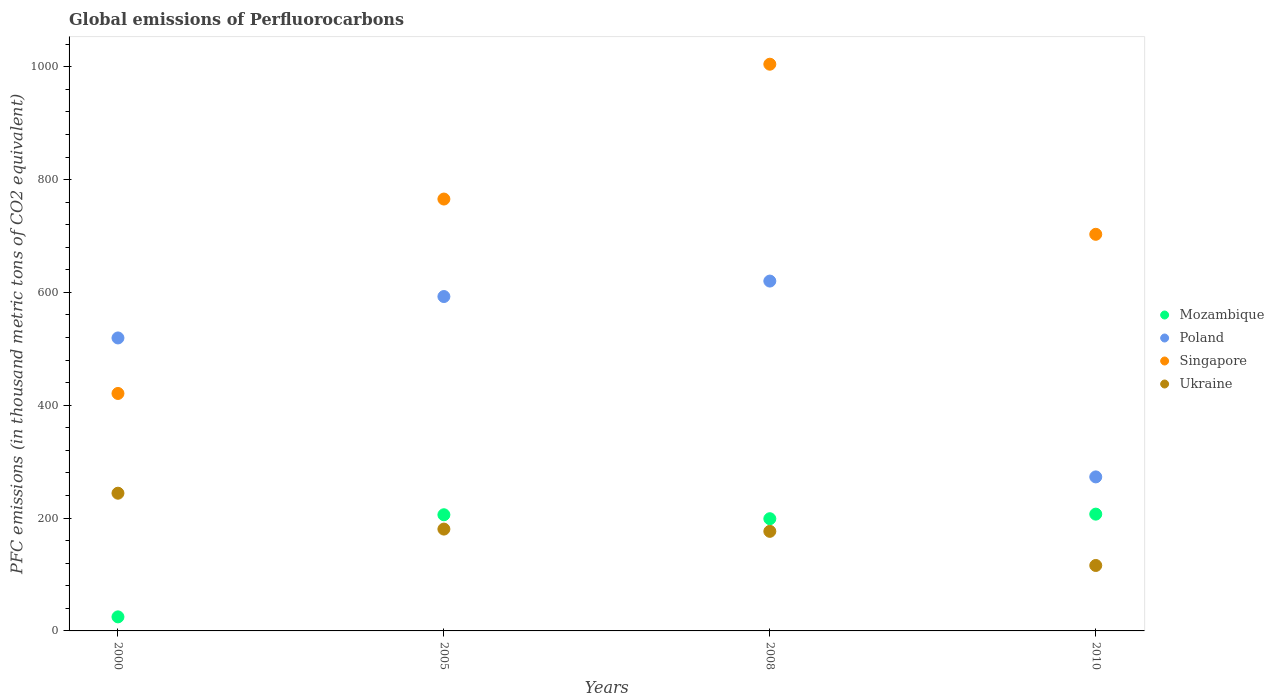What is the global emissions of Perfluorocarbons in Ukraine in 2005?
Provide a succinct answer. 180.5. Across all years, what is the maximum global emissions of Perfluorocarbons in Poland?
Offer a terse response. 620.1. Across all years, what is the minimum global emissions of Perfluorocarbons in Ukraine?
Your answer should be very brief. 116. In which year was the global emissions of Perfluorocarbons in Poland maximum?
Make the answer very short. 2008. In which year was the global emissions of Perfluorocarbons in Mozambique minimum?
Your answer should be very brief. 2000. What is the total global emissions of Perfluorocarbons in Singapore in the graph?
Offer a terse response. 2893.9. What is the difference between the global emissions of Perfluorocarbons in Singapore in 2000 and that in 2005?
Your answer should be very brief. -344.6. What is the difference between the global emissions of Perfluorocarbons in Poland in 2000 and the global emissions of Perfluorocarbons in Mozambique in 2010?
Offer a terse response. 312.3. What is the average global emissions of Perfluorocarbons in Mozambique per year?
Make the answer very short. 159.18. In the year 2010, what is the difference between the global emissions of Perfluorocarbons in Mozambique and global emissions of Perfluorocarbons in Ukraine?
Your answer should be compact. 91. What is the ratio of the global emissions of Perfluorocarbons in Mozambique in 2005 to that in 2008?
Provide a succinct answer. 1.04. What is the difference between the highest and the second highest global emissions of Perfluorocarbons in Singapore?
Make the answer very short. 239. What is the difference between the highest and the lowest global emissions of Perfluorocarbons in Mozambique?
Your answer should be compact. 182.1. In how many years, is the global emissions of Perfluorocarbons in Ukraine greater than the average global emissions of Perfluorocarbons in Ukraine taken over all years?
Your answer should be compact. 2. Is the sum of the global emissions of Perfluorocarbons in Mozambique in 2000 and 2005 greater than the maximum global emissions of Perfluorocarbons in Poland across all years?
Your response must be concise. No. Is the global emissions of Perfluorocarbons in Poland strictly greater than the global emissions of Perfluorocarbons in Ukraine over the years?
Keep it short and to the point. Yes. Is the global emissions of Perfluorocarbons in Mozambique strictly less than the global emissions of Perfluorocarbons in Singapore over the years?
Make the answer very short. Yes. How many dotlines are there?
Offer a very short reply. 4. How many years are there in the graph?
Provide a succinct answer. 4. Are the values on the major ticks of Y-axis written in scientific E-notation?
Your answer should be very brief. No. How are the legend labels stacked?
Your answer should be very brief. Vertical. What is the title of the graph?
Provide a short and direct response. Global emissions of Perfluorocarbons. What is the label or title of the X-axis?
Make the answer very short. Years. What is the label or title of the Y-axis?
Keep it short and to the point. PFC emissions (in thousand metric tons of CO2 equivalent). What is the PFC emissions (in thousand metric tons of CO2 equivalent) in Mozambique in 2000?
Give a very brief answer. 24.9. What is the PFC emissions (in thousand metric tons of CO2 equivalent) of Poland in 2000?
Your answer should be very brief. 519.3. What is the PFC emissions (in thousand metric tons of CO2 equivalent) of Singapore in 2000?
Make the answer very short. 420.9. What is the PFC emissions (in thousand metric tons of CO2 equivalent) of Ukraine in 2000?
Offer a very short reply. 244.1. What is the PFC emissions (in thousand metric tons of CO2 equivalent) of Mozambique in 2005?
Your response must be concise. 205.9. What is the PFC emissions (in thousand metric tons of CO2 equivalent) of Poland in 2005?
Provide a short and direct response. 592.7. What is the PFC emissions (in thousand metric tons of CO2 equivalent) in Singapore in 2005?
Keep it short and to the point. 765.5. What is the PFC emissions (in thousand metric tons of CO2 equivalent) of Ukraine in 2005?
Your response must be concise. 180.5. What is the PFC emissions (in thousand metric tons of CO2 equivalent) in Mozambique in 2008?
Your answer should be very brief. 198.9. What is the PFC emissions (in thousand metric tons of CO2 equivalent) in Poland in 2008?
Give a very brief answer. 620.1. What is the PFC emissions (in thousand metric tons of CO2 equivalent) in Singapore in 2008?
Keep it short and to the point. 1004.5. What is the PFC emissions (in thousand metric tons of CO2 equivalent) in Ukraine in 2008?
Ensure brevity in your answer.  176.5. What is the PFC emissions (in thousand metric tons of CO2 equivalent) in Mozambique in 2010?
Your answer should be very brief. 207. What is the PFC emissions (in thousand metric tons of CO2 equivalent) in Poland in 2010?
Your answer should be compact. 273. What is the PFC emissions (in thousand metric tons of CO2 equivalent) in Singapore in 2010?
Your response must be concise. 703. What is the PFC emissions (in thousand metric tons of CO2 equivalent) of Ukraine in 2010?
Your answer should be compact. 116. Across all years, what is the maximum PFC emissions (in thousand metric tons of CO2 equivalent) in Mozambique?
Your answer should be compact. 207. Across all years, what is the maximum PFC emissions (in thousand metric tons of CO2 equivalent) in Poland?
Provide a short and direct response. 620.1. Across all years, what is the maximum PFC emissions (in thousand metric tons of CO2 equivalent) of Singapore?
Keep it short and to the point. 1004.5. Across all years, what is the maximum PFC emissions (in thousand metric tons of CO2 equivalent) of Ukraine?
Provide a succinct answer. 244.1. Across all years, what is the minimum PFC emissions (in thousand metric tons of CO2 equivalent) in Mozambique?
Give a very brief answer. 24.9. Across all years, what is the minimum PFC emissions (in thousand metric tons of CO2 equivalent) in Poland?
Offer a terse response. 273. Across all years, what is the minimum PFC emissions (in thousand metric tons of CO2 equivalent) in Singapore?
Your answer should be compact. 420.9. Across all years, what is the minimum PFC emissions (in thousand metric tons of CO2 equivalent) of Ukraine?
Ensure brevity in your answer.  116. What is the total PFC emissions (in thousand metric tons of CO2 equivalent) in Mozambique in the graph?
Provide a short and direct response. 636.7. What is the total PFC emissions (in thousand metric tons of CO2 equivalent) in Poland in the graph?
Offer a very short reply. 2005.1. What is the total PFC emissions (in thousand metric tons of CO2 equivalent) of Singapore in the graph?
Keep it short and to the point. 2893.9. What is the total PFC emissions (in thousand metric tons of CO2 equivalent) in Ukraine in the graph?
Give a very brief answer. 717.1. What is the difference between the PFC emissions (in thousand metric tons of CO2 equivalent) of Mozambique in 2000 and that in 2005?
Your response must be concise. -181. What is the difference between the PFC emissions (in thousand metric tons of CO2 equivalent) of Poland in 2000 and that in 2005?
Keep it short and to the point. -73.4. What is the difference between the PFC emissions (in thousand metric tons of CO2 equivalent) of Singapore in 2000 and that in 2005?
Keep it short and to the point. -344.6. What is the difference between the PFC emissions (in thousand metric tons of CO2 equivalent) of Ukraine in 2000 and that in 2005?
Your answer should be very brief. 63.6. What is the difference between the PFC emissions (in thousand metric tons of CO2 equivalent) in Mozambique in 2000 and that in 2008?
Ensure brevity in your answer.  -174. What is the difference between the PFC emissions (in thousand metric tons of CO2 equivalent) in Poland in 2000 and that in 2008?
Your answer should be compact. -100.8. What is the difference between the PFC emissions (in thousand metric tons of CO2 equivalent) of Singapore in 2000 and that in 2008?
Your answer should be compact. -583.6. What is the difference between the PFC emissions (in thousand metric tons of CO2 equivalent) in Ukraine in 2000 and that in 2008?
Your response must be concise. 67.6. What is the difference between the PFC emissions (in thousand metric tons of CO2 equivalent) of Mozambique in 2000 and that in 2010?
Your response must be concise. -182.1. What is the difference between the PFC emissions (in thousand metric tons of CO2 equivalent) in Poland in 2000 and that in 2010?
Make the answer very short. 246.3. What is the difference between the PFC emissions (in thousand metric tons of CO2 equivalent) of Singapore in 2000 and that in 2010?
Ensure brevity in your answer.  -282.1. What is the difference between the PFC emissions (in thousand metric tons of CO2 equivalent) of Ukraine in 2000 and that in 2010?
Keep it short and to the point. 128.1. What is the difference between the PFC emissions (in thousand metric tons of CO2 equivalent) of Mozambique in 2005 and that in 2008?
Keep it short and to the point. 7. What is the difference between the PFC emissions (in thousand metric tons of CO2 equivalent) in Poland in 2005 and that in 2008?
Make the answer very short. -27.4. What is the difference between the PFC emissions (in thousand metric tons of CO2 equivalent) in Singapore in 2005 and that in 2008?
Provide a succinct answer. -239. What is the difference between the PFC emissions (in thousand metric tons of CO2 equivalent) of Ukraine in 2005 and that in 2008?
Offer a very short reply. 4. What is the difference between the PFC emissions (in thousand metric tons of CO2 equivalent) of Poland in 2005 and that in 2010?
Your answer should be very brief. 319.7. What is the difference between the PFC emissions (in thousand metric tons of CO2 equivalent) of Singapore in 2005 and that in 2010?
Make the answer very short. 62.5. What is the difference between the PFC emissions (in thousand metric tons of CO2 equivalent) in Ukraine in 2005 and that in 2010?
Your answer should be very brief. 64.5. What is the difference between the PFC emissions (in thousand metric tons of CO2 equivalent) in Poland in 2008 and that in 2010?
Your answer should be very brief. 347.1. What is the difference between the PFC emissions (in thousand metric tons of CO2 equivalent) of Singapore in 2008 and that in 2010?
Provide a short and direct response. 301.5. What is the difference between the PFC emissions (in thousand metric tons of CO2 equivalent) of Ukraine in 2008 and that in 2010?
Ensure brevity in your answer.  60.5. What is the difference between the PFC emissions (in thousand metric tons of CO2 equivalent) of Mozambique in 2000 and the PFC emissions (in thousand metric tons of CO2 equivalent) of Poland in 2005?
Ensure brevity in your answer.  -567.8. What is the difference between the PFC emissions (in thousand metric tons of CO2 equivalent) in Mozambique in 2000 and the PFC emissions (in thousand metric tons of CO2 equivalent) in Singapore in 2005?
Keep it short and to the point. -740.6. What is the difference between the PFC emissions (in thousand metric tons of CO2 equivalent) of Mozambique in 2000 and the PFC emissions (in thousand metric tons of CO2 equivalent) of Ukraine in 2005?
Offer a very short reply. -155.6. What is the difference between the PFC emissions (in thousand metric tons of CO2 equivalent) of Poland in 2000 and the PFC emissions (in thousand metric tons of CO2 equivalent) of Singapore in 2005?
Provide a succinct answer. -246.2. What is the difference between the PFC emissions (in thousand metric tons of CO2 equivalent) of Poland in 2000 and the PFC emissions (in thousand metric tons of CO2 equivalent) of Ukraine in 2005?
Keep it short and to the point. 338.8. What is the difference between the PFC emissions (in thousand metric tons of CO2 equivalent) of Singapore in 2000 and the PFC emissions (in thousand metric tons of CO2 equivalent) of Ukraine in 2005?
Provide a succinct answer. 240.4. What is the difference between the PFC emissions (in thousand metric tons of CO2 equivalent) in Mozambique in 2000 and the PFC emissions (in thousand metric tons of CO2 equivalent) in Poland in 2008?
Your answer should be very brief. -595.2. What is the difference between the PFC emissions (in thousand metric tons of CO2 equivalent) of Mozambique in 2000 and the PFC emissions (in thousand metric tons of CO2 equivalent) of Singapore in 2008?
Ensure brevity in your answer.  -979.6. What is the difference between the PFC emissions (in thousand metric tons of CO2 equivalent) in Mozambique in 2000 and the PFC emissions (in thousand metric tons of CO2 equivalent) in Ukraine in 2008?
Offer a terse response. -151.6. What is the difference between the PFC emissions (in thousand metric tons of CO2 equivalent) in Poland in 2000 and the PFC emissions (in thousand metric tons of CO2 equivalent) in Singapore in 2008?
Ensure brevity in your answer.  -485.2. What is the difference between the PFC emissions (in thousand metric tons of CO2 equivalent) in Poland in 2000 and the PFC emissions (in thousand metric tons of CO2 equivalent) in Ukraine in 2008?
Keep it short and to the point. 342.8. What is the difference between the PFC emissions (in thousand metric tons of CO2 equivalent) in Singapore in 2000 and the PFC emissions (in thousand metric tons of CO2 equivalent) in Ukraine in 2008?
Your answer should be compact. 244.4. What is the difference between the PFC emissions (in thousand metric tons of CO2 equivalent) in Mozambique in 2000 and the PFC emissions (in thousand metric tons of CO2 equivalent) in Poland in 2010?
Provide a succinct answer. -248.1. What is the difference between the PFC emissions (in thousand metric tons of CO2 equivalent) in Mozambique in 2000 and the PFC emissions (in thousand metric tons of CO2 equivalent) in Singapore in 2010?
Provide a succinct answer. -678.1. What is the difference between the PFC emissions (in thousand metric tons of CO2 equivalent) in Mozambique in 2000 and the PFC emissions (in thousand metric tons of CO2 equivalent) in Ukraine in 2010?
Offer a terse response. -91.1. What is the difference between the PFC emissions (in thousand metric tons of CO2 equivalent) of Poland in 2000 and the PFC emissions (in thousand metric tons of CO2 equivalent) of Singapore in 2010?
Ensure brevity in your answer.  -183.7. What is the difference between the PFC emissions (in thousand metric tons of CO2 equivalent) of Poland in 2000 and the PFC emissions (in thousand metric tons of CO2 equivalent) of Ukraine in 2010?
Offer a very short reply. 403.3. What is the difference between the PFC emissions (in thousand metric tons of CO2 equivalent) of Singapore in 2000 and the PFC emissions (in thousand metric tons of CO2 equivalent) of Ukraine in 2010?
Keep it short and to the point. 304.9. What is the difference between the PFC emissions (in thousand metric tons of CO2 equivalent) of Mozambique in 2005 and the PFC emissions (in thousand metric tons of CO2 equivalent) of Poland in 2008?
Your answer should be compact. -414.2. What is the difference between the PFC emissions (in thousand metric tons of CO2 equivalent) in Mozambique in 2005 and the PFC emissions (in thousand metric tons of CO2 equivalent) in Singapore in 2008?
Make the answer very short. -798.6. What is the difference between the PFC emissions (in thousand metric tons of CO2 equivalent) in Mozambique in 2005 and the PFC emissions (in thousand metric tons of CO2 equivalent) in Ukraine in 2008?
Your answer should be compact. 29.4. What is the difference between the PFC emissions (in thousand metric tons of CO2 equivalent) in Poland in 2005 and the PFC emissions (in thousand metric tons of CO2 equivalent) in Singapore in 2008?
Give a very brief answer. -411.8. What is the difference between the PFC emissions (in thousand metric tons of CO2 equivalent) of Poland in 2005 and the PFC emissions (in thousand metric tons of CO2 equivalent) of Ukraine in 2008?
Ensure brevity in your answer.  416.2. What is the difference between the PFC emissions (in thousand metric tons of CO2 equivalent) of Singapore in 2005 and the PFC emissions (in thousand metric tons of CO2 equivalent) of Ukraine in 2008?
Offer a terse response. 589. What is the difference between the PFC emissions (in thousand metric tons of CO2 equivalent) in Mozambique in 2005 and the PFC emissions (in thousand metric tons of CO2 equivalent) in Poland in 2010?
Offer a terse response. -67.1. What is the difference between the PFC emissions (in thousand metric tons of CO2 equivalent) in Mozambique in 2005 and the PFC emissions (in thousand metric tons of CO2 equivalent) in Singapore in 2010?
Give a very brief answer. -497.1. What is the difference between the PFC emissions (in thousand metric tons of CO2 equivalent) in Mozambique in 2005 and the PFC emissions (in thousand metric tons of CO2 equivalent) in Ukraine in 2010?
Offer a terse response. 89.9. What is the difference between the PFC emissions (in thousand metric tons of CO2 equivalent) in Poland in 2005 and the PFC emissions (in thousand metric tons of CO2 equivalent) in Singapore in 2010?
Ensure brevity in your answer.  -110.3. What is the difference between the PFC emissions (in thousand metric tons of CO2 equivalent) in Poland in 2005 and the PFC emissions (in thousand metric tons of CO2 equivalent) in Ukraine in 2010?
Offer a very short reply. 476.7. What is the difference between the PFC emissions (in thousand metric tons of CO2 equivalent) in Singapore in 2005 and the PFC emissions (in thousand metric tons of CO2 equivalent) in Ukraine in 2010?
Your answer should be very brief. 649.5. What is the difference between the PFC emissions (in thousand metric tons of CO2 equivalent) in Mozambique in 2008 and the PFC emissions (in thousand metric tons of CO2 equivalent) in Poland in 2010?
Offer a very short reply. -74.1. What is the difference between the PFC emissions (in thousand metric tons of CO2 equivalent) of Mozambique in 2008 and the PFC emissions (in thousand metric tons of CO2 equivalent) of Singapore in 2010?
Offer a very short reply. -504.1. What is the difference between the PFC emissions (in thousand metric tons of CO2 equivalent) of Mozambique in 2008 and the PFC emissions (in thousand metric tons of CO2 equivalent) of Ukraine in 2010?
Offer a terse response. 82.9. What is the difference between the PFC emissions (in thousand metric tons of CO2 equivalent) of Poland in 2008 and the PFC emissions (in thousand metric tons of CO2 equivalent) of Singapore in 2010?
Your answer should be very brief. -82.9. What is the difference between the PFC emissions (in thousand metric tons of CO2 equivalent) of Poland in 2008 and the PFC emissions (in thousand metric tons of CO2 equivalent) of Ukraine in 2010?
Give a very brief answer. 504.1. What is the difference between the PFC emissions (in thousand metric tons of CO2 equivalent) of Singapore in 2008 and the PFC emissions (in thousand metric tons of CO2 equivalent) of Ukraine in 2010?
Ensure brevity in your answer.  888.5. What is the average PFC emissions (in thousand metric tons of CO2 equivalent) of Mozambique per year?
Ensure brevity in your answer.  159.18. What is the average PFC emissions (in thousand metric tons of CO2 equivalent) in Poland per year?
Keep it short and to the point. 501.27. What is the average PFC emissions (in thousand metric tons of CO2 equivalent) in Singapore per year?
Offer a terse response. 723.48. What is the average PFC emissions (in thousand metric tons of CO2 equivalent) of Ukraine per year?
Offer a very short reply. 179.28. In the year 2000, what is the difference between the PFC emissions (in thousand metric tons of CO2 equivalent) of Mozambique and PFC emissions (in thousand metric tons of CO2 equivalent) of Poland?
Your answer should be compact. -494.4. In the year 2000, what is the difference between the PFC emissions (in thousand metric tons of CO2 equivalent) of Mozambique and PFC emissions (in thousand metric tons of CO2 equivalent) of Singapore?
Ensure brevity in your answer.  -396. In the year 2000, what is the difference between the PFC emissions (in thousand metric tons of CO2 equivalent) in Mozambique and PFC emissions (in thousand metric tons of CO2 equivalent) in Ukraine?
Provide a succinct answer. -219.2. In the year 2000, what is the difference between the PFC emissions (in thousand metric tons of CO2 equivalent) in Poland and PFC emissions (in thousand metric tons of CO2 equivalent) in Singapore?
Provide a short and direct response. 98.4. In the year 2000, what is the difference between the PFC emissions (in thousand metric tons of CO2 equivalent) in Poland and PFC emissions (in thousand metric tons of CO2 equivalent) in Ukraine?
Make the answer very short. 275.2. In the year 2000, what is the difference between the PFC emissions (in thousand metric tons of CO2 equivalent) in Singapore and PFC emissions (in thousand metric tons of CO2 equivalent) in Ukraine?
Give a very brief answer. 176.8. In the year 2005, what is the difference between the PFC emissions (in thousand metric tons of CO2 equivalent) of Mozambique and PFC emissions (in thousand metric tons of CO2 equivalent) of Poland?
Make the answer very short. -386.8. In the year 2005, what is the difference between the PFC emissions (in thousand metric tons of CO2 equivalent) of Mozambique and PFC emissions (in thousand metric tons of CO2 equivalent) of Singapore?
Your answer should be very brief. -559.6. In the year 2005, what is the difference between the PFC emissions (in thousand metric tons of CO2 equivalent) in Mozambique and PFC emissions (in thousand metric tons of CO2 equivalent) in Ukraine?
Offer a terse response. 25.4. In the year 2005, what is the difference between the PFC emissions (in thousand metric tons of CO2 equivalent) in Poland and PFC emissions (in thousand metric tons of CO2 equivalent) in Singapore?
Offer a very short reply. -172.8. In the year 2005, what is the difference between the PFC emissions (in thousand metric tons of CO2 equivalent) of Poland and PFC emissions (in thousand metric tons of CO2 equivalent) of Ukraine?
Keep it short and to the point. 412.2. In the year 2005, what is the difference between the PFC emissions (in thousand metric tons of CO2 equivalent) of Singapore and PFC emissions (in thousand metric tons of CO2 equivalent) of Ukraine?
Make the answer very short. 585. In the year 2008, what is the difference between the PFC emissions (in thousand metric tons of CO2 equivalent) in Mozambique and PFC emissions (in thousand metric tons of CO2 equivalent) in Poland?
Give a very brief answer. -421.2. In the year 2008, what is the difference between the PFC emissions (in thousand metric tons of CO2 equivalent) of Mozambique and PFC emissions (in thousand metric tons of CO2 equivalent) of Singapore?
Provide a short and direct response. -805.6. In the year 2008, what is the difference between the PFC emissions (in thousand metric tons of CO2 equivalent) of Mozambique and PFC emissions (in thousand metric tons of CO2 equivalent) of Ukraine?
Give a very brief answer. 22.4. In the year 2008, what is the difference between the PFC emissions (in thousand metric tons of CO2 equivalent) in Poland and PFC emissions (in thousand metric tons of CO2 equivalent) in Singapore?
Ensure brevity in your answer.  -384.4. In the year 2008, what is the difference between the PFC emissions (in thousand metric tons of CO2 equivalent) of Poland and PFC emissions (in thousand metric tons of CO2 equivalent) of Ukraine?
Provide a short and direct response. 443.6. In the year 2008, what is the difference between the PFC emissions (in thousand metric tons of CO2 equivalent) in Singapore and PFC emissions (in thousand metric tons of CO2 equivalent) in Ukraine?
Provide a short and direct response. 828. In the year 2010, what is the difference between the PFC emissions (in thousand metric tons of CO2 equivalent) of Mozambique and PFC emissions (in thousand metric tons of CO2 equivalent) of Poland?
Offer a very short reply. -66. In the year 2010, what is the difference between the PFC emissions (in thousand metric tons of CO2 equivalent) of Mozambique and PFC emissions (in thousand metric tons of CO2 equivalent) of Singapore?
Make the answer very short. -496. In the year 2010, what is the difference between the PFC emissions (in thousand metric tons of CO2 equivalent) of Mozambique and PFC emissions (in thousand metric tons of CO2 equivalent) of Ukraine?
Keep it short and to the point. 91. In the year 2010, what is the difference between the PFC emissions (in thousand metric tons of CO2 equivalent) of Poland and PFC emissions (in thousand metric tons of CO2 equivalent) of Singapore?
Offer a very short reply. -430. In the year 2010, what is the difference between the PFC emissions (in thousand metric tons of CO2 equivalent) in Poland and PFC emissions (in thousand metric tons of CO2 equivalent) in Ukraine?
Give a very brief answer. 157. In the year 2010, what is the difference between the PFC emissions (in thousand metric tons of CO2 equivalent) in Singapore and PFC emissions (in thousand metric tons of CO2 equivalent) in Ukraine?
Your response must be concise. 587. What is the ratio of the PFC emissions (in thousand metric tons of CO2 equivalent) in Mozambique in 2000 to that in 2005?
Your answer should be compact. 0.12. What is the ratio of the PFC emissions (in thousand metric tons of CO2 equivalent) of Poland in 2000 to that in 2005?
Provide a short and direct response. 0.88. What is the ratio of the PFC emissions (in thousand metric tons of CO2 equivalent) of Singapore in 2000 to that in 2005?
Your answer should be compact. 0.55. What is the ratio of the PFC emissions (in thousand metric tons of CO2 equivalent) in Ukraine in 2000 to that in 2005?
Keep it short and to the point. 1.35. What is the ratio of the PFC emissions (in thousand metric tons of CO2 equivalent) of Mozambique in 2000 to that in 2008?
Your answer should be very brief. 0.13. What is the ratio of the PFC emissions (in thousand metric tons of CO2 equivalent) of Poland in 2000 to that in 2008?
Provide a short and direct response. 0.84. What is the ratio of the PFC emissions (in thousand metric tons of CO2 equivalent) of Singapore in 2000 to that in 2008?
Provide a short and direct response. 0.42. What is the ratio of the PFC emissions (in thousand metric tons of CO2 equivalent) in Ukraine in 2000 to that in 2008?
Keep it short and to the point. 1.38. What is the ratio of the PFC emissions (in thousand metric tons of CO2 equivalent) of Mozambique in 2000 to that in 2010?
Provide a short and direct response. 0.12. What is the ratio of the PFC emissions (in thousand metric tons of CO2 equivalent) in Poland in 2000 to that in 2010?
Give a very brief answer. 1.9. What is the ratio of the PFC emissions (in thousand metric tons of CO2 equivalent) in Singapore in 2000 to that in 2010?
Give a very brief answer. 0.6. What is the ratio of the PFC emissions (in thousand metric tons of CO2 equivalent) in Ukraine in 2000 to that in 2010?
Keep it short and to the point. 2.1. What is the ratio of the PFC emissions (in thousand metric tons of CO2 equivalent) of Mozambique in 2005 to that in 2008?
Give a very brief answer. 1.04. What is the ratio of the PFC emissions (in thousand metric tons of CO2 equivalent) in Poland in 2005 to that in 2008?
Your response must be concise. 0.96. What is the ratio of the PFC emissions (in thousand metric tons of CO2 equivalent) in Singapore in 2005 to that in 2008?
Offer a terse response. 0.76. What is the ratio of the PFC emissions (in thousand metric tons of CO2 equivalent) of Ukraine in 2005 to that in 2008?
Ensure brevity in your answer.  1.02. What is the ratio of the PFC emissions (in thousand metric tons of CO2 equivalent) of Mozambique in 2005 to that in 2010?
Keep it short and to the point. 0.99. What is the ratio of the PFC emissions (in thousand metric tons of CO2 equivalent) of Poland in 2005 to that in 2010?
Make the answer very short. 2.17. What is the ratio of the PFC emissions (in thousand metric tons of CO2 equivalent) in Singapore in 2005 to that in 2010?
Keep it short and to the point. 1.09. What is the ratio of the PFC emissions (in thousand metric tons of CO2 equivalent) in Ukraine in 2005 to that in 2010?
Ensure brevity in your answer.  1.56. What is the ratio of the PFC emissions (in thousand metric tons of CO2 equivalent) of Mozambique in 2008 to that in 2010?
Give a very brief answer. 0.96. What is the ratio of the PFC emissions (in thousand metric tons of CO2 equivalent) in Poland in 2008 to that in 2010?
Keep it short and to the point. 2.27. What is the ratio of the PFC emissions (in thousand metric tons of CO2 equivalent) in Singapore in 2008 to that in 2010?
Keep it short and to the point. 1.43. What is the ratio of the PFC emissions (in thousand metric tons of CO2 equivalent) in Ukraine in 2008 to that in 2010?
Make the answer very short. 1.52. What is the difference between the highest and the second highest PFC emissions (in thousand metric tons of CO2 equivalent) in Mozambique?
Give a very brief answer. 1.1. What is the difference between the highest and the second highest PFC emissions (in thousand metric tons of CO2 equivalent) in Poland?
Your answer should be very brief. 27.4. What is the difference between the highest and the second highest PFC emissions (in thousand metric tons of CO2 equivalent) in Singapore?
Offer a terse response. 239. What is the difference between the highest and the second highest PFC emissions (in thousand metric tons of CO2 equivalent) of Ukraine?
Your response must be concise. 63.6. What is the difference between the highest and the lowest PFC emissions (in thousand metric tons of CO2 equivalent) in Mozambique?
Keep it short and to the point. 182.1. What is the difference between the highest and the lowest PFC emissions (in thousand metric tons of CO2 equivalent) in Poland?
Your answer should be very brief. 347.1. What is the difference between the highest and the lowest PFC emissions (in thousand metric tons of CO2 equivalent) of Singapore?
Your answer should be very brief. 583.6. What is the difference between the highest and the lowest PFC emissions (in thousand metric tons of CO2 equivalent) in Ukraine?
Offer a very short reply. 128.1. 